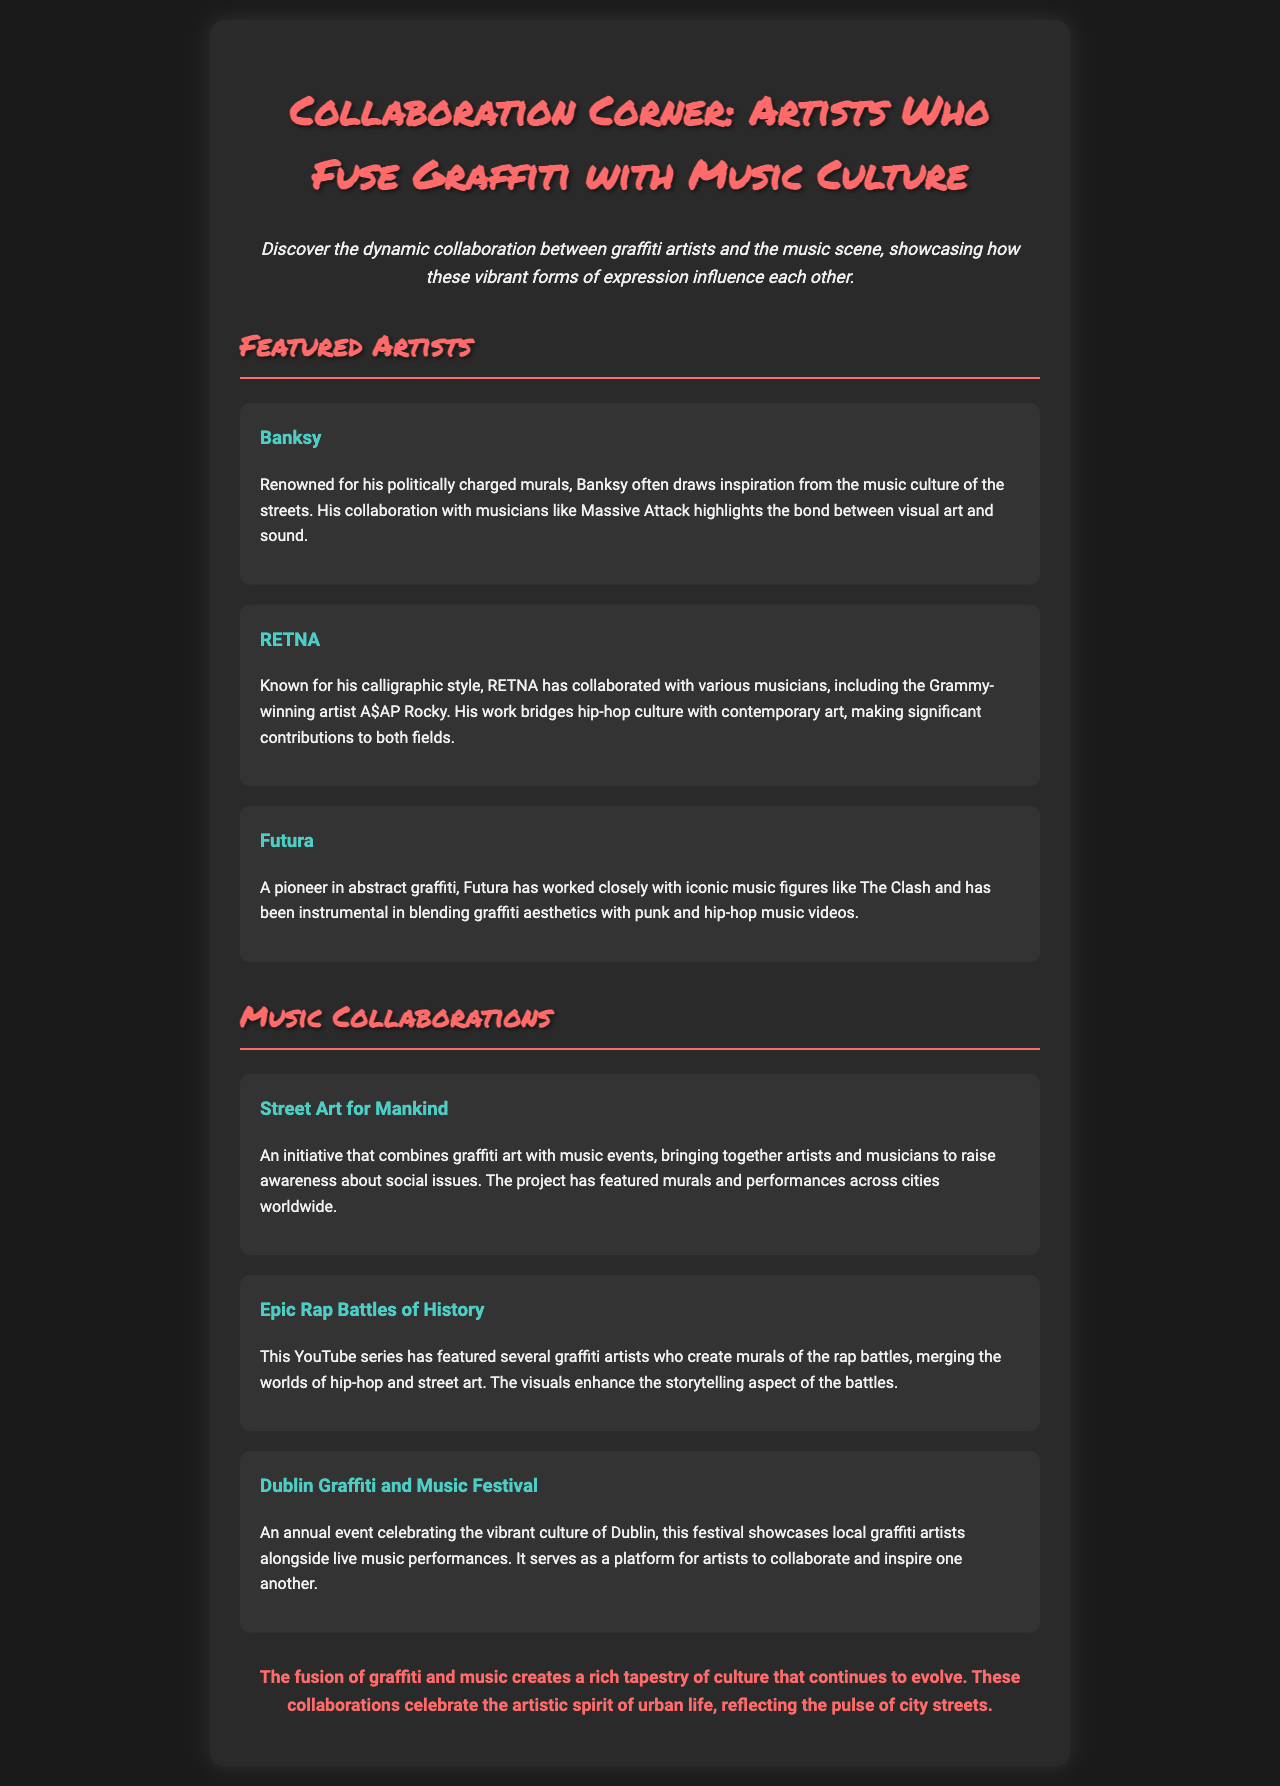What is the title of the newsletter? The title of the newsletter is presented prominently at the top of the document, which is "Collaboration Corner: Artists Who Fuse Graffiti with Music Culture."
Answer: Collaboration Corner: Artists Who Fuse Graffiti with Music Culture Who is known for his politically charged murals? This information is directly mentioned in the section about featured artists, specifically regarding Banksy.
Answer: Banksy Which artist collaborated with A$AP Rocky? The document states that RETNA has collaborated with the Grammy-winning artist A$AP Rocky.
Answer: RETNA What initiative combines graffiti art with music events? The newsletter describes an initiative called "Street Art for Mankind" that merges these two cultural aspects.
Answer: Street Art for Mankind Which festival celebrates both graffiti art and music in Dublin? The document mentions the "Dublin Graffiti and Music Festival" as an event focused on this fusion.
Answer: Dublin Graffiti and Music Festival How many featured artists are listed in the document? To find the answer, count the names mentioned in the Featured Artists section of the newsletter. There are three artists listed.
Answer: 3 What aspect of culture do graffiti and music collaborations reflect? The conclusion of the document summarizes this aspect as reflecting the "pulse of city streets."
Answer: pulse of city streets Which collaboration enhances the storytelling aspect of rap battles? The document specifically refers to "Epic Rap Battles of History" as merging visuals with storytelling.
Answer: Epic Rap Battles of History 